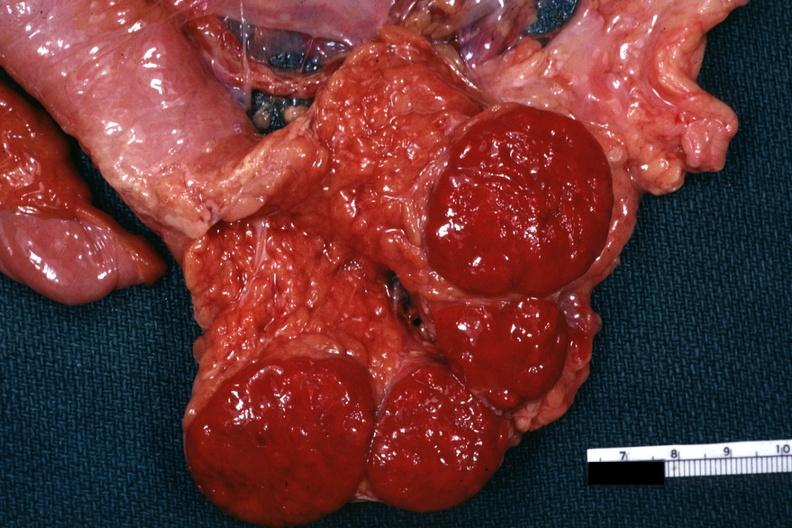how does this image show tail of pancreas?
Answer the question using a single word or phrase. With spleens 